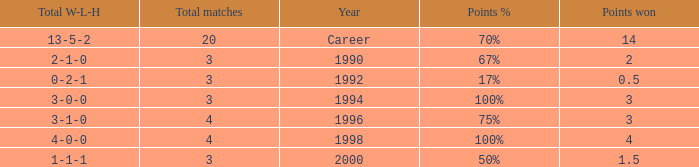Can you inform me about the minimum total matches resulting in 3 points won in the year 1994? 3.0. 